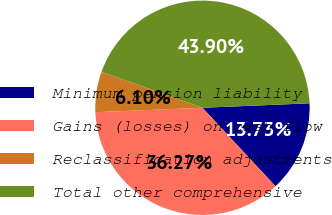Convert chart. <chart><loc_0><loc_0><loc_500><loc_500><pie_chart><fcel>Minimum pension liability<fcel>Gains (losses) on cash flow<fcel>Reclassification adjustments<fcel>Total other comprehensive<nl><fcel>13.73%<fcel>36.27%<fcel>6.1%<fcel>43.9%<nl></chart> 